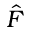<formula> <loc_0><loc_0><loc_500><loc_500>\hat { F }</formula> 